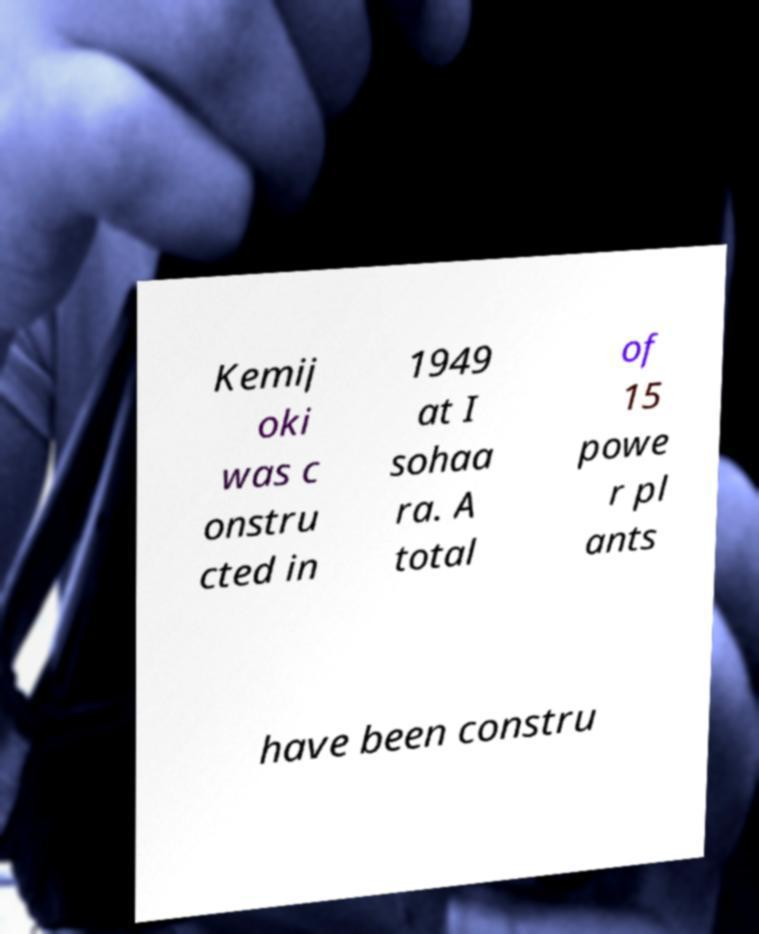For documentation purposes, I need the text within this image transcribed. Could you provide that? Kemij oki was c onstru cted in 1949 at I sohaa ra. A total of 15 powe r pl ants have been constru 